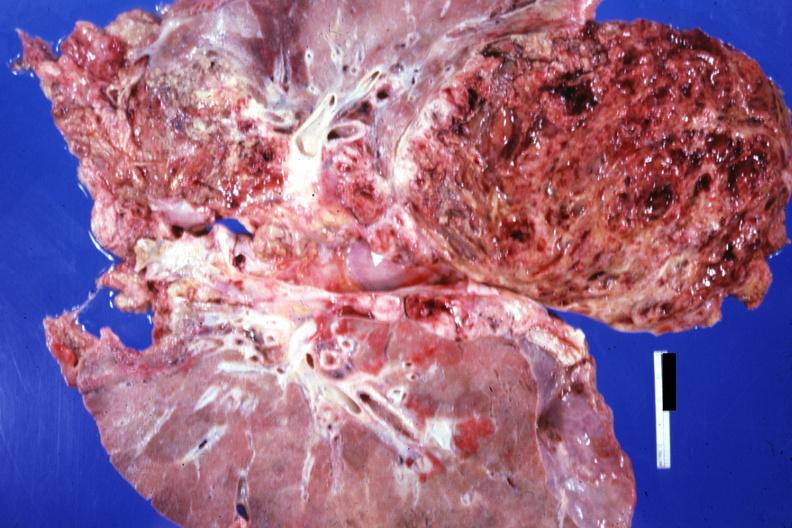what does this image show?
Answer the question using a single word or phrase. Frontal section of lungs and massive tumor teratocarcinoma 20yowm 